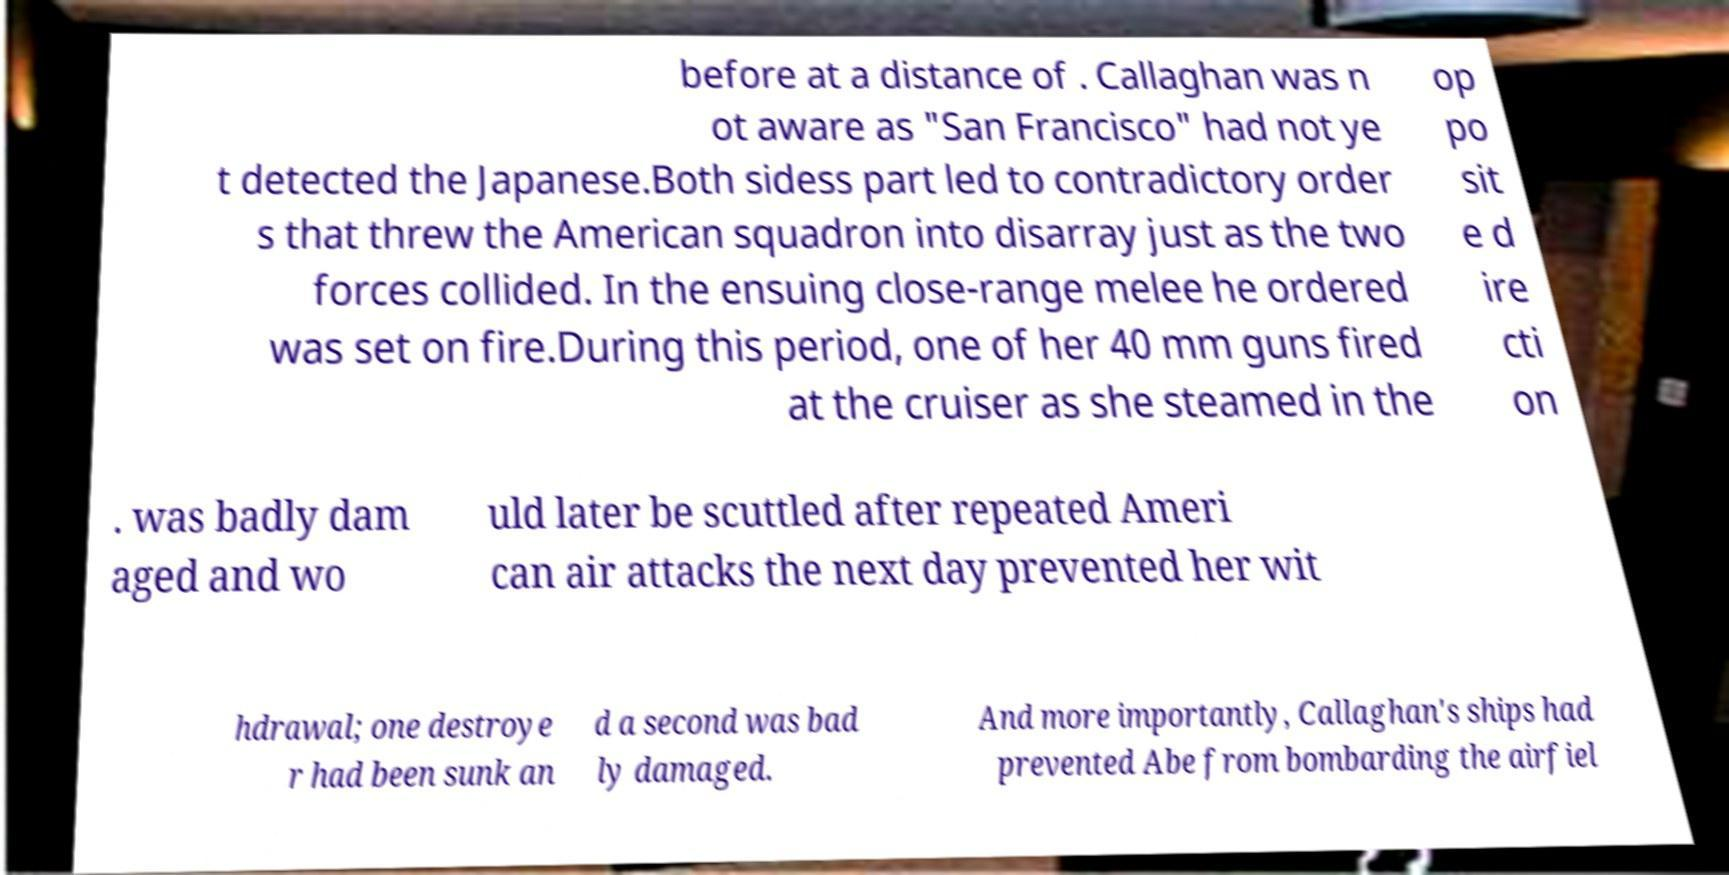Can you read and provide the text displayed in the image?This photo seems to have some interesting text. Can you extract and type it out for me? before at a distance of . Callaghan was n ot aware as "San Francisco" had not ye t detected the Japanese.Both sidess part led to contradictory order s that threw the American squadron into disarray just as the two forces collided. In the ensuing close-range melee he ordered was set on fire.During this period, one of her 40 mm guns fired at the cruiser as she steamed in the op po sit e d ire cti on . was badly dam aged and wo uld later be scuttled after repeated Ameri can air attacks the next day prevented her wit hdrawal; one destroye r had been sunk an d a second was bad ly damaged. And more importantly, Callaghan's ships had prevented Abe from bombarding the airfiel 